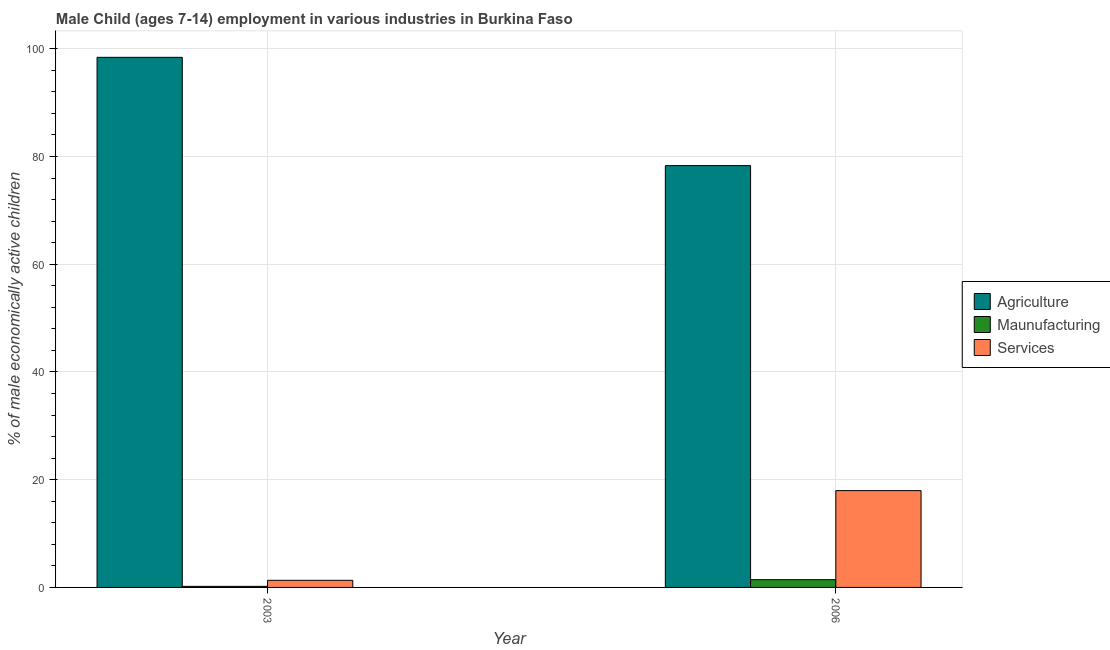How many different coloured bars are there?
Keep it short and to the point. 3. How many bars are there on the 1st tick from the left?
Offer a very short reply. 3. What is the label of the 1st group of bars from the left?
Ensure brevity in your answer.  2003. In how many cases, is the number of bars for a given year not equal to the number of legend labels?
Keep it short and to the point. 0. What is the percentage of economically active children in services in 2006?
Ensure brevity in your answer.  17.97. Across all years, what is the maximum percentage of economically active children in services?
Give a very brief answer. 17.97. Across all years, what is the minimum percentage of economically active children in agriculture?
Your answer should be compact. 78.3. In which year was the percentage of economically active children in services maximum?
Offer a very short reply. 2006. In which year was the percentage of economically active children in agriculture minimum?
Provide a succinct answer. 2006. What is the total percentage of economically active children in manufacturing in the graph?
Your answer should be compact. 1.64. What is the difference between the percentage of economically active children in agriculture in 2003 and that in 2006?
Your answer should be compact. 20.1. What is the difference between the percentage of economically active children in manufacturing in 2006 and the percentage of economically active children in services in 2003?
Make the answer very short. 1.24. What is the average percentage of economically active children in services per year?
Offer a terse response. 9.65. What is the ratio of the percentage of economically active children in agriculture in 2003 to that in 2006?
Provide a short and direct response. 1.26. What does the 2nd bar from the left in 2006 represents?
Give a very brief answer. Maunufacturing. What does the 1st bar from the right in 2003 represents?
Provide a succinct answer. Services. How many bars are there?
Offer a very short reply. 6. What is the difference between two consecutive major ticks on the Y-axis?
Offer a terse response. 20. Are the values on the major ticks of Y-axis written in scientific E-notation?
Offer a terse response. No. Does the graph contain grids?
Provide a short and direct response. Yes. What is the title of the graph?
Your answer should be compact. Male Child (ages 7-14) employment in various industries in Burkina Faso. What is the label or title of the X-axis?
Offer a terse response. Year. What is the label or title of the Y-axis?
Your answer should be very brief. % of male economically active children. What is the % of male economically active children of Agriculture in 2003?
Provide a short and direct response. 98.4. What is the % of male economically active children in Maunufacturing in 2003?
Your answer should be compact. 0.2. What is the % of male economically active children of Services in 2003?
Provide a succinct answer. 1.32. What is the % of male economically active children of Agriculture in 2006?
Provide a succinct answer. 78.3. What is the % of male economically active children in Maunufacturing in 2006?
Make the answer very short. 1.44. What is the % of male economically active children in Services in 2006?
Your answer should be compact. 17.97. Across all years, what is the maximum % of male economically active children of Agriculture?
Your response must be concise. 98.4. Across all years, what is the maximum % of male economically active children of Maunufacturing?
Offer a terse response. 1.44. Across all years, what is the maximum % of male economically active children of Services?
Provide a short and direct response. 17.97. Across all years, what is the minimum % of male economically active children in Agriculture?
Offer a terse response. 78.3. Across all years, what is the minimum % of male economically active children of Maunufacturing?
Offer a terse response. 0.2. Across all years, what is the minimum % of male economically active children of Services?
Your answer should be compact. 1.32. What is the total % of male economically active children in Agriculture in the graph?
Offer a terse response. 176.7. What is the total % of male economically active children of Maunufacturing in the graph?
Your response must be concise. 1.64. What is the total % of male economically active children of Services in the graph?
Offer a terse response. 19.29. What is the difference between the % of male economically active children in Agriculture in 2003 and that in 2006?
Your answer should be compact. 20.1. What is the difference between the % of male economically active children of Maunufacturing in 2003 and that in 2006?
Your response must be concise. -1.24. What is the difference between the % of male economically active children of Services in 2003 and that in 2006?
Give a very brief answer. -16.65. What is the difference between the % of male economically active children of Agriculture in 2003 and the % of male economically active children of Maunufacturing in 2006?
Offer a very short reply. 96.96. What is the difference between the % of male economically active children of Agriculture in 2003 and the % of male economically active children of Services in 2006?
Provide a short and direct response. 80.43. What is the difference between the % of male economically active children of Maunufacturing in 2003 and the % of male economically active children of Services in 2006?
Give a very brief answer. -17.77. What is the average % of male economically active children of Agriculture per year?
Make the answer very short. 88.35. What is the average % of male economically active children of Maunufacturing per year?
Provide a succinct answer. 0.82. What is the average % of male economically active children of Services per year?
Provide a short and direct response. 9.65. In the year 2003, what is the difference between the % of male economically active children in Agriculture and % of male economically active children in Maunufacturing?
Ensure brevity in your answer.  98.2. In the year 2003, what is the difference between the % of male economically active children of Agriculture and % of male economically active children of Services?
Your answer should be compact. 97.08. In the year 2003, what is the difference between the % of male economically active children in Maunufacturing and % of male economically active children in Services?
Provide a short and direct response. -1.12. In the year 2006, what is the difference between the % of male economically active children of Agriculture and % of male economically active children of Maunufacturing?
Offer a very short reply. 76.86. In the year 2006, what is the difference between the % of male economically active children of Agriculture and % of male economically active children of Services?
Offer a terse response. 60.33. In the year 2006, what is the difference between the % of male economically active children of Maunufacturing and % of male economically active children of Services?
Give a very brief answer. -16.53. What is the ratio of the % of male economically active children of Agriculture in 2003 to that in 2006?
Your response must be concise. 1.26. What is the ratio of the % of male economically active children of Maunufacturing in 2003 to that in 2006?
Your response must be concise. 0.14. What is the ratio of the % of male economically active children of Services in 2003 to that in 2006?
Offer a terse response. 0.07. What is the difference between the highest and the second highest % of male economically active children in Agriculture?
Your answer should be compact. 20.1. What is the difference between the highest and the second highest % of male economically active children in Maunufacturing?
Your answer should be very brief. 1.24. What is the difference between the highest and the second highest % of male economically active children of Services?
Ensure brevity in your answer.  16.65. What is the difference between the highest and the lowest % of male economically active children of Agriculture?
Your answer should be compact. 20.1. What is the difference between the highest and the lowest % of male economically active children in Maunufacturing?
Offer a terse response. 1.24. What is the difference between the highest and the lowest % of male economically active children of Services?
Your answer should be compact. 16.65. 